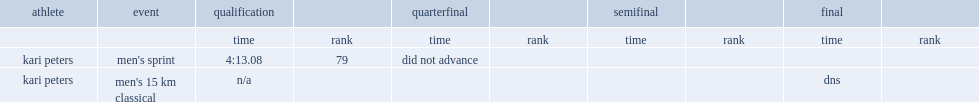What is the final result for kari peters tooking part in the men's sprint? 4:13.08. 